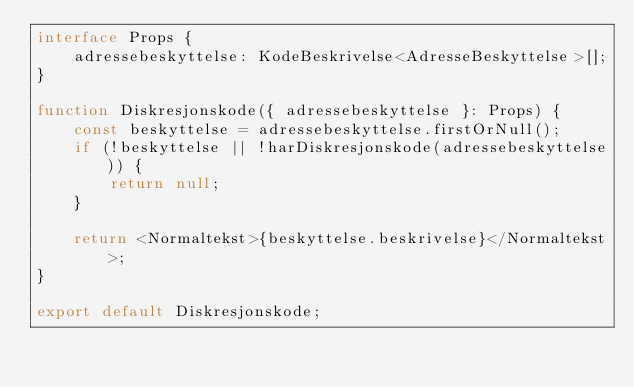Convert code to text. <code><loc_0><loc_0><loc_500><loc_500><_TypeScript_>interface Props {
    adressebeskyttelse: KodeBeskrivelse<AdresseBeskyttelse>[];
}

function Diskresjonskode({ adressebeskyttelse }: Props) {
    const beskyttelse = adressebeskyttelse.firstOrNull();
    if (!beskyttelse || !harDiskresjonskode(adressebeskyttelse)) {
        return null;
    }

    return <Normaltekst>{beskyttelse.beskrivelse}</Normaltekst>;
}

export default Diskresjonskode;
</code> 